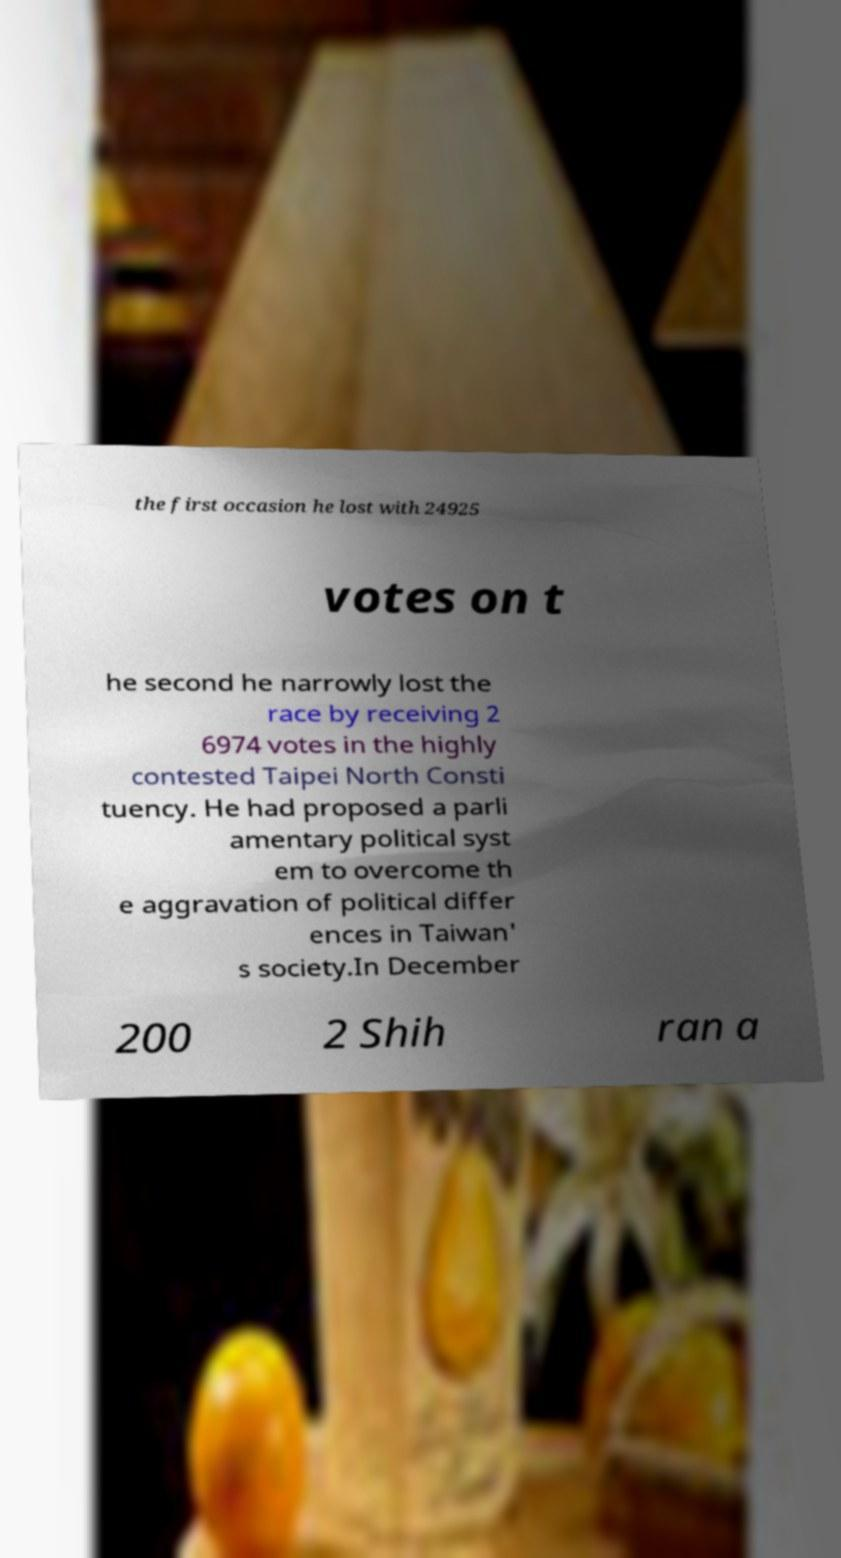For documentation purposes, I need the text within this image transcribed. Could you provide that? the first occasion he lost with 24925 votes on t he second he narrowly lost the race by receiving 2 6974 votes in the highly contested Taipei North Consti tuency. He had proposed a parli amentary political syst em to overcome th e aggravation of political differ ences in Taiwan' s society.In December 200 2 Shih ran a 